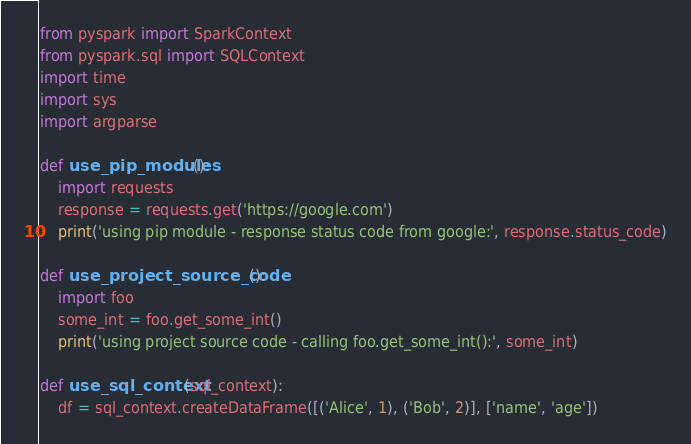Convert code to text. <code><loc_0><loc_0><loc_500><loc_500><_Python_>from pyspark import SparkContext
from pyspark.sql import SQLContext
import time
import sys
import argparse

def use_pip_modules():
    import requests    
    response = requests.get('https://google.com') 
    print('using pip module - response status code from google:', response.status_code)

def use_project_source_code():
    import foo
    some_int = foo.get_some_int()
    print('using project source code - calling foo.get_some_int():', some_int)

def use_sql_context(sql_context):
    df = sql_context.createDataFrame([('Alice', 1), ('Bob', 2)], ['name', 'age'])</code> 